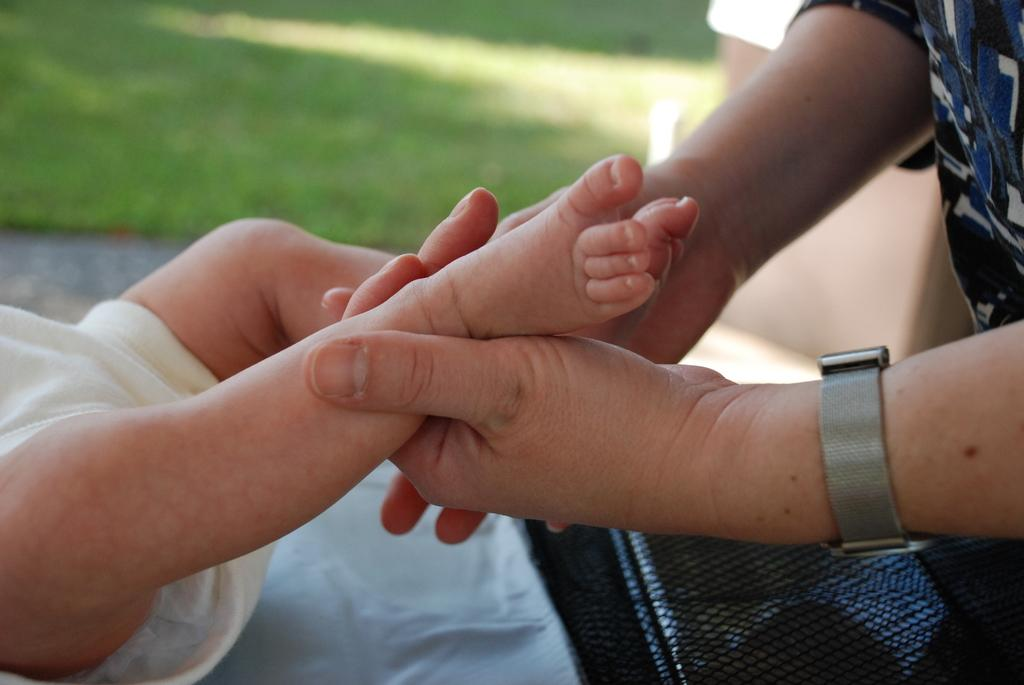What is the main subject of the image? There is a person in the image. What is the person doing in the image? The person is holding a baby's leg. Can you describe the person's face in the image? The person's face is not visible in the image. How would you describe the background of the image? The background of the image is blurred. What type of ornament is hanging from the ceiling in the image? There is no ornament hanging from the ceiling in the image. Is there any evidence of a space-themed exchange happening in the image? There is no reference to a space-themed exchange or any space-related elements in the image. 